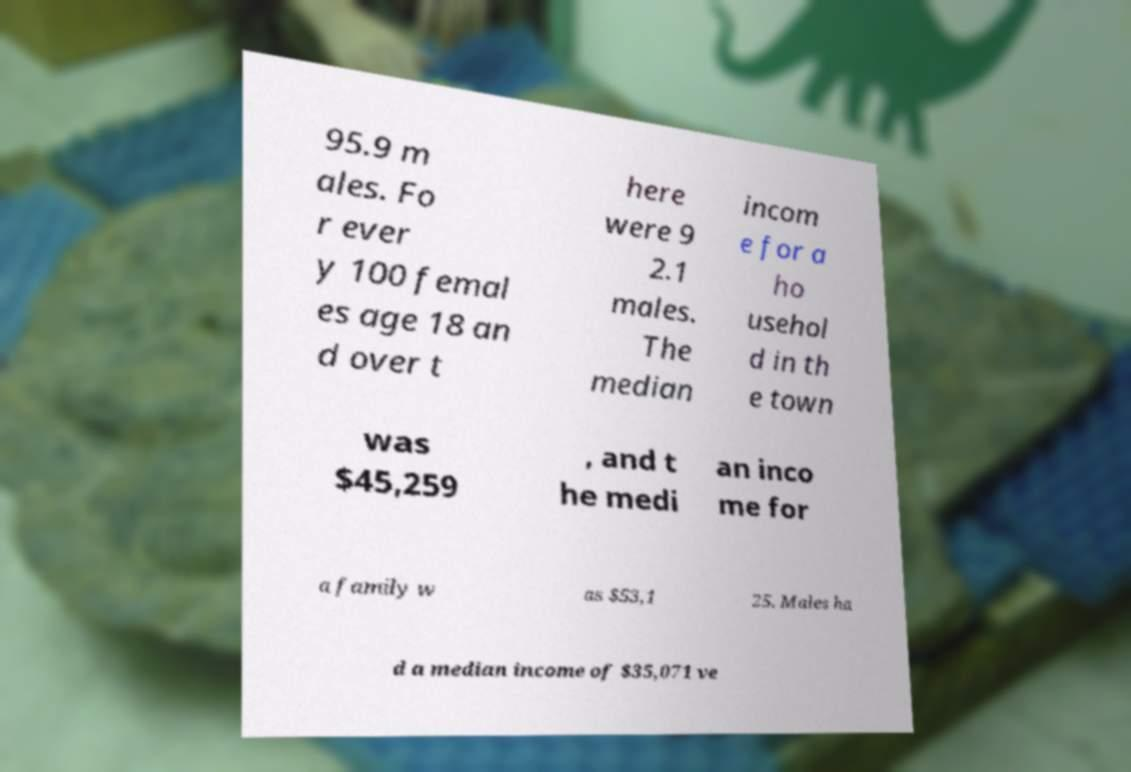Could you assist in decoding the text presented in this image and type it out clearly? 95.9 m ales. Fo r ever y 100 femal es age 18 an d over t here were 9 2.1 males. The median incom e for a ho usehol d in th e town was $45,259 , and t he medi an inco me for a family w as $53,1 25. Males ha d a median income of $35,071 ve 